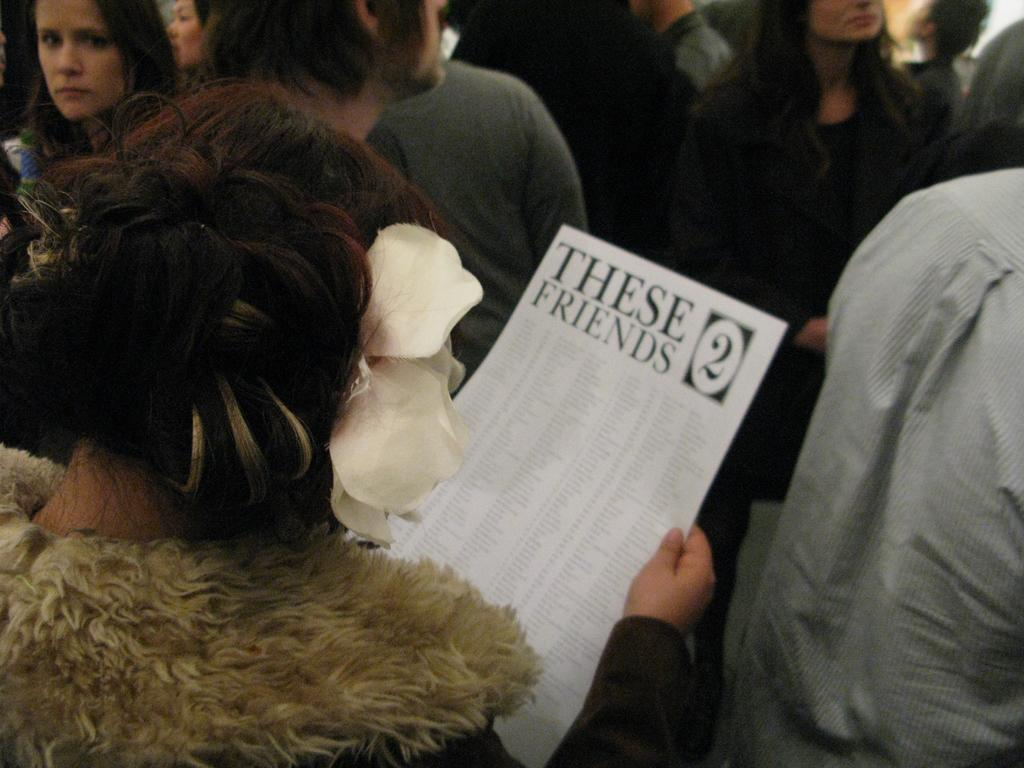What is happening in the image? There are many people standing on the floor in the image. Can you describe the woman on the left side of the image? A woman is holding a paper in her hand on the left side of the image. What is the company's belief about the effect of the paper on the people in the image? There is no company or belief mentioned in the image, and therefore no such information can be determined. 